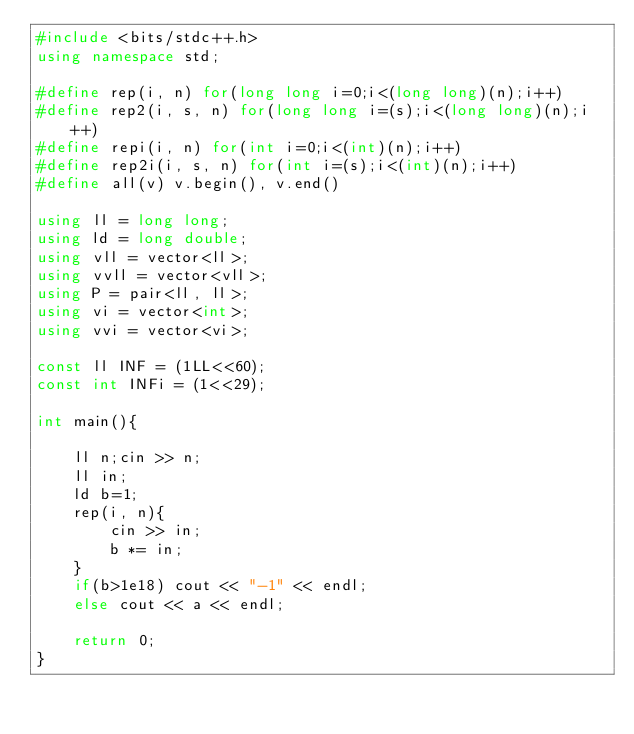<code> <loc_0><loc_0><loc_500><loc_500><_C++_>#include <bits/stdc++.h>
using namespace std;

#define rep(i, n) for(long long i=0;i<(long long)(n);i++)
#define rep2(i, s, n) for(long long i=(s);i<(long long)(n);i++)
#define repi(i, n) for(int i=0;i<(int)(n);i++)
#define rep2i(i, s, n) for(int i=(s);i<(int)(n);i++)
#define all(v) v.begin(), v.end()

using ll = long long;
using ld = long double;
using vll = vector<ll>;
using vvll = vector<vll>;
using P = pair<ll, ll>;
using vi = vector<int>;
using vvi = vector<vi>;

const ll INF = (1LL<<60);
const int INFi = (1<<29);

int main(){

    ll n;cin >> n;
    ll in;
    ld b=1;
    rep(i, n){
        cin >> in;
        b *= in;
    }
    if(b>1e18) cout << "-1" << endl;
    else cout << a << endl;

    return 0;
}</code> 